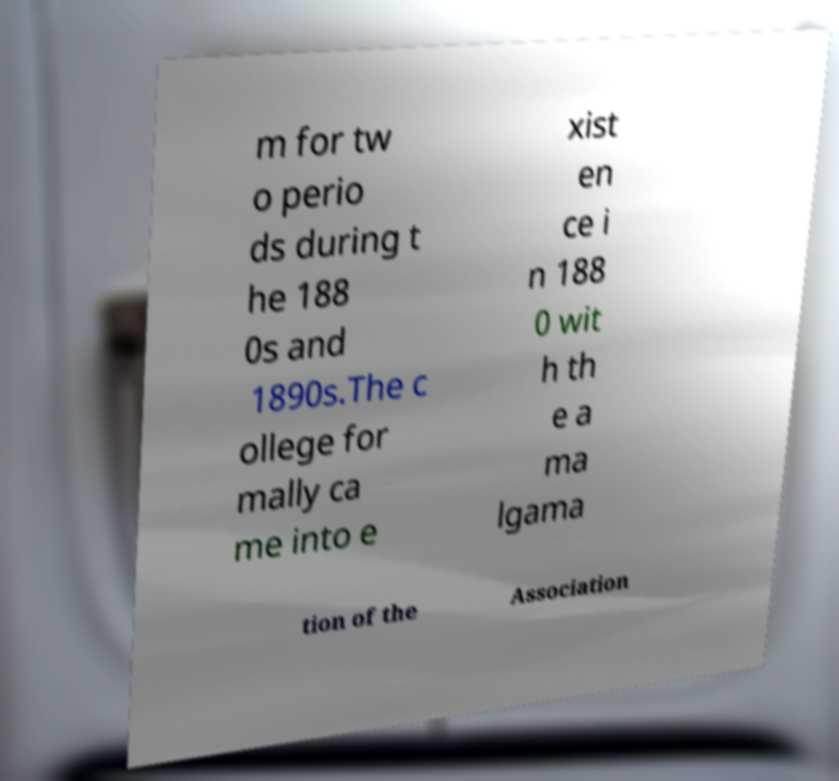For documentation purposes, I need the text within this image transcribed. Could you provide that? m for tw o perio ds during t he 188 0s and 1890s.The c ollege for mally ca me into e xist en ce i n 188 0 wit h th e a ma lgama tion of the Association 